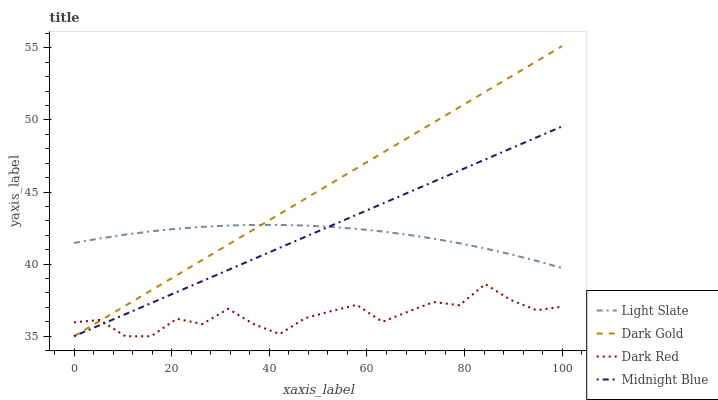Does Dark Red have the minimum area under the curve?
Answer yes or no. Yes. Does Dark Gold have the maximum area under the curve?
Answer yes or no. Yes. Does Midnight Blue have the minimum area under the curve?
Answer yes or no. No. Does Midnight Blue have the maximum area under the curve?
Answer yes or no. No. Is Midnight Blue the smoothest?
Answer yes or no. Yes. Is Dark Red the roughest?
Answer yes or no. Yes. Is Dark Red the smoothest?
Answer yes or no. No. Is Midnight Blue the roughest?
Answer yes or no. No. Does Dark Red have the lowest value?
Answer yes or no. Yes. Does Dark Gold have the highest value?
Answer yes or no. Yes. Does Midnight Blue have the highest value?
Answer yes or no. No. Is Dark Red less than Light Slate?
Answer yes or no. Yes. Is Light Slate greater than Dark Red?
Answer yes or no. Yes. Does Light Slate intersect Dark Gold?
Answer yes or no. Yes. Is Light Slate less than Dark Gold?
Answer yes or no. No. Is Light Slate greater than Dark Gold?
Answer yes or no. No. Does Dark Red intersect Light Slate?
Answer yes or no. No. 